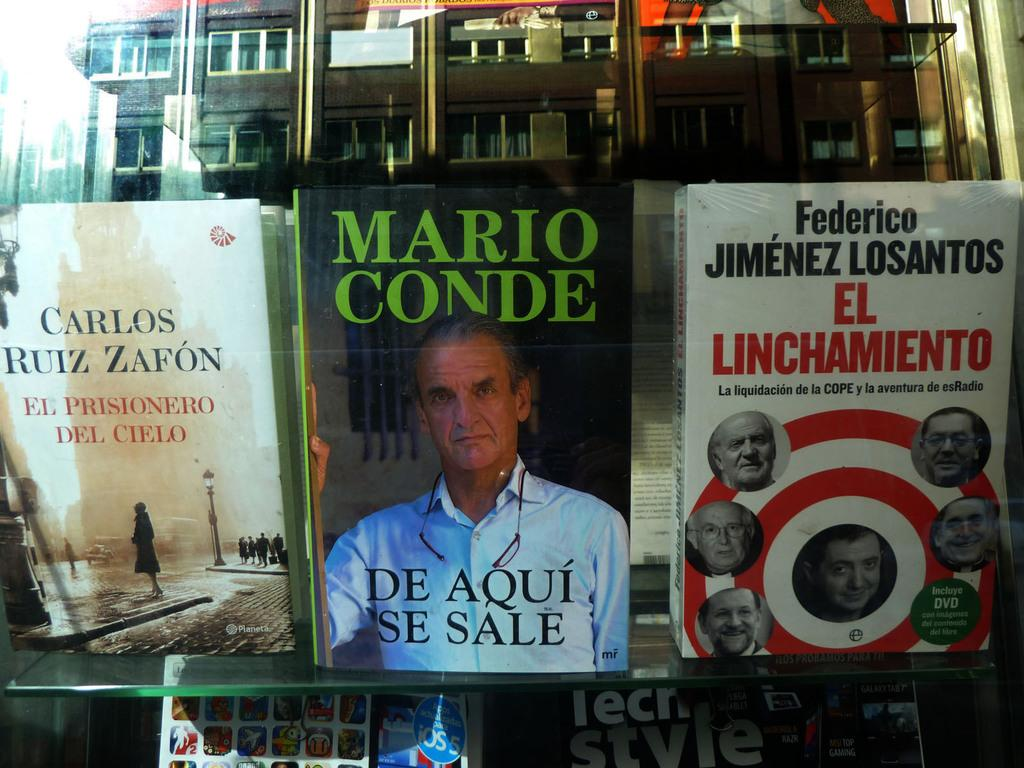<image>
Provide a brief description of the given image. Several books sit on display in a window and one called De Aqui Se Sale was written by Mario Conde. 